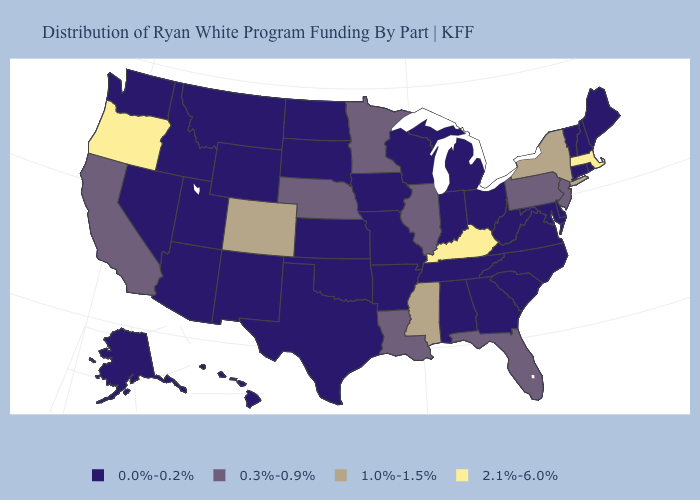Name the states that have a value in the range 0.3%-0.9%?
Keep it brief. California, Florida, Illinois, Louisiana, Minnesota, Nebraska, New Jersey, Pennsylvania. Which states hav the highest value in the West?
Write a very short answer. Oregon. Does Delaware have the same value as Kentucky?
Short answer required. No. What is the value of Pennsylvania?
Answer briefly. 0.3%-0.9%. What is the lowest value in the USA?
Quick response, please. 0.0%-0.2%. What is the value of Maryland?
Be succinct. 0.0%-0.2%. What is the lowest value in states that border New Jersey?
Answer briefly. 0.0%-0.2%. What is the highest value in the USA?
Be succinct. 2.1%-6.0%. What is the value of Iowa?
Quick response, please. 0.0%-0.2%. Does the map have missing data?
Be succinct. No. What is the value of Delaware?
Be succinct. 0.0%-0.2%. Does Arizona have the highest value in the West?
Write a very short answer. No. What is the value of Kansas?
Quick response, please. 0.0%-0.2%. What is the value of North Carolina?
Short answer required. 0.0%-0.2%. Is the legend a continuous bar?
Give a very brief answer. No. 